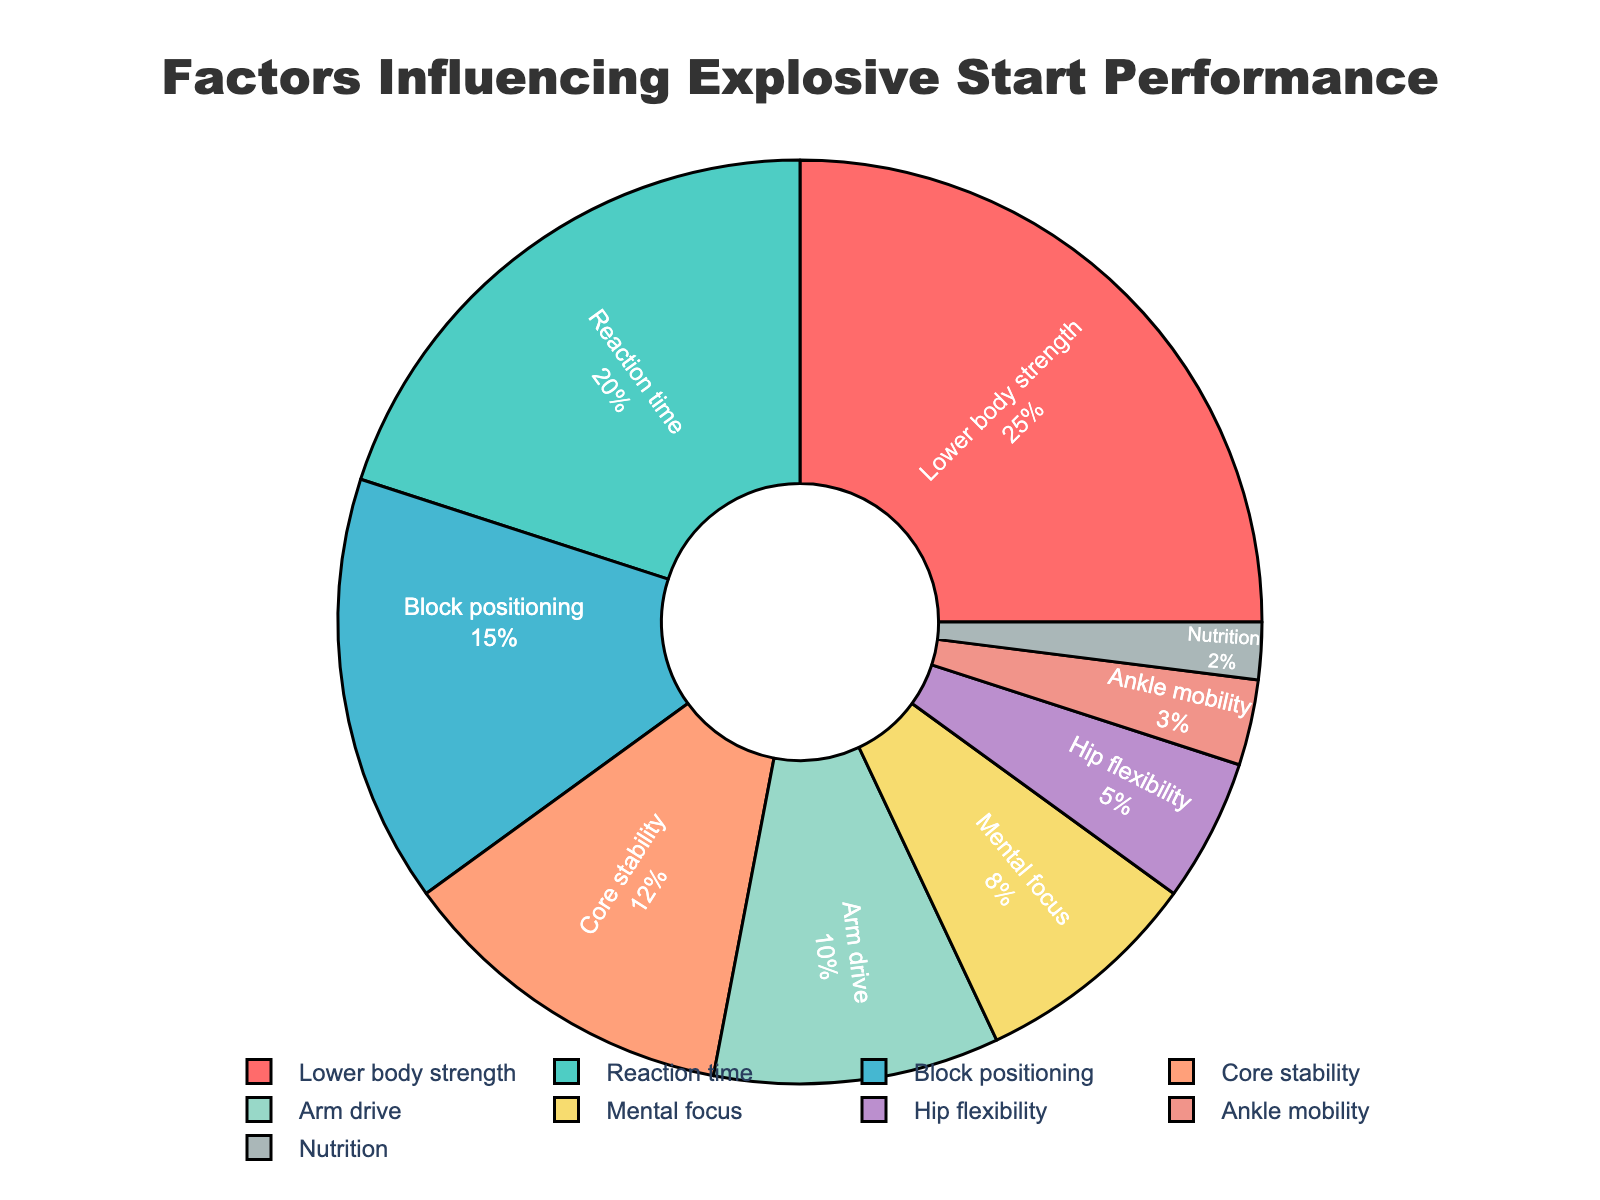Which factor has the highest percentage? The figure shows a pie chart with different factors. The largest segment is labeled "Lower body strength" with a percentage of 25%.
Answer: Lower body strength What is the combined percentage of Reaction time and Mental focus? According to the chart, Reaction time is 20% and Mental focus is 8%. Adding these gives us 20% + 8% = 28%.
Answer: 28% Which factor contributes less, Arm drive or Hip flexibility? By looking at the pie chart, Arm drive is 10% and Hip flexibility is 5%. Hence, Hip flexibility contributes less.
Answer: Hip flexibility How much more does Lower body strength contribute compared to Nutrition? Lower body strength has a 25% contribution, while Nutrition has 2%. The difference is 25% - 2% = 23%.
Answer: 23% Is the combined percentage of Core stability and Block positioning greater than that of Reaction time? Core stability is 12% and Block positioning is 15%. Their combined percentage is 12% + 15% = 27%, which is greater than Reaction time's 20%.
Answer: Yes Which segment is visually the smallest on the chart? The pie chart shows Ankle mobility with the smallest segment, labeled as 3%.
Answer: Ankle mobility What is the total percentage of factors related specifically to mobility or flexibility: Hip flexibility and Ankle mobility? The chart indicates Hip flexibility is 5% and Ankle mobility is 3%. Adding these gives us 5% + 3% = 8%.
Answer: 8% How does the percentage of Block positioning compare to Arm drive? The chart shows Block positioning at 15% and Arm drive at 10%. Block positioning is 5% higher than Arm drive.
Answer: Block positioning is higher by 5% What percentage more does Mental focus contribute compared to Nutrition? Mental focus contributes 8% and Nutrition contributes 2%. The difference is 8% - 2% = 6%.
Answer: 6% What is the second most influential factor according to the chart? The second largest segment after Lower body strength (25%) is Reaction time with 20%.
Answer: Reaction time 